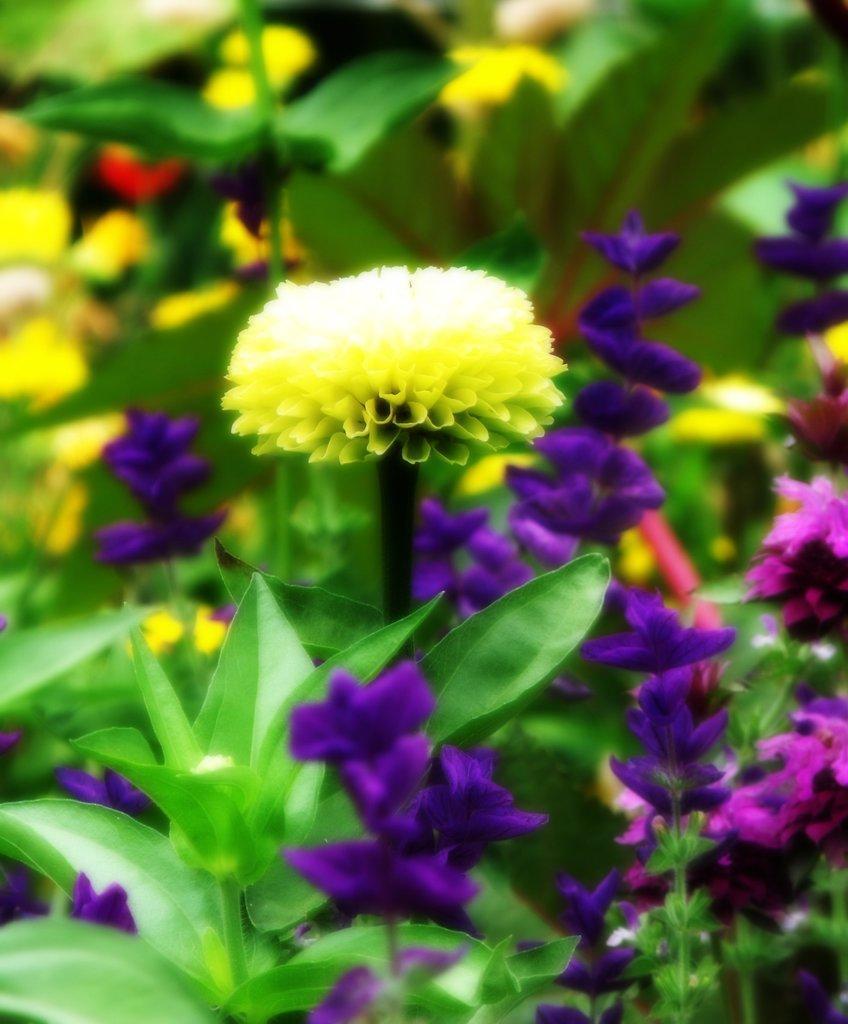Please provide a concise description of this image. This is an edited picture. In this picture there are plants and flowers. 